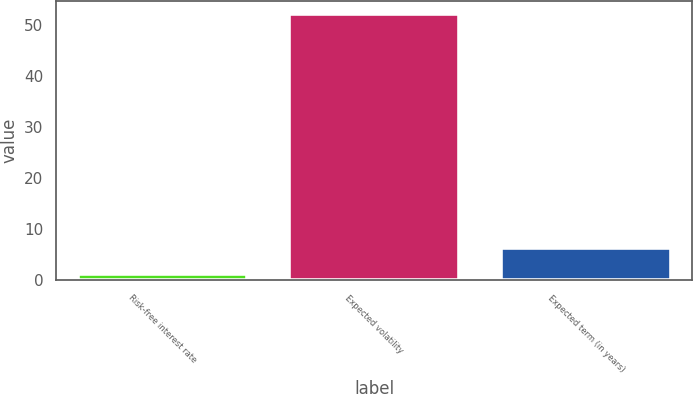Convert chart. <chart><loc_0><loc_0><loc_500><loc_500><bar_chart><fcel>Risk-free interest rate<fcel>Expected volatility<fcel>Expected term (in years)<nl><fcel>1.24<fcel>52.14<fcel>6.33<nl></chart> 